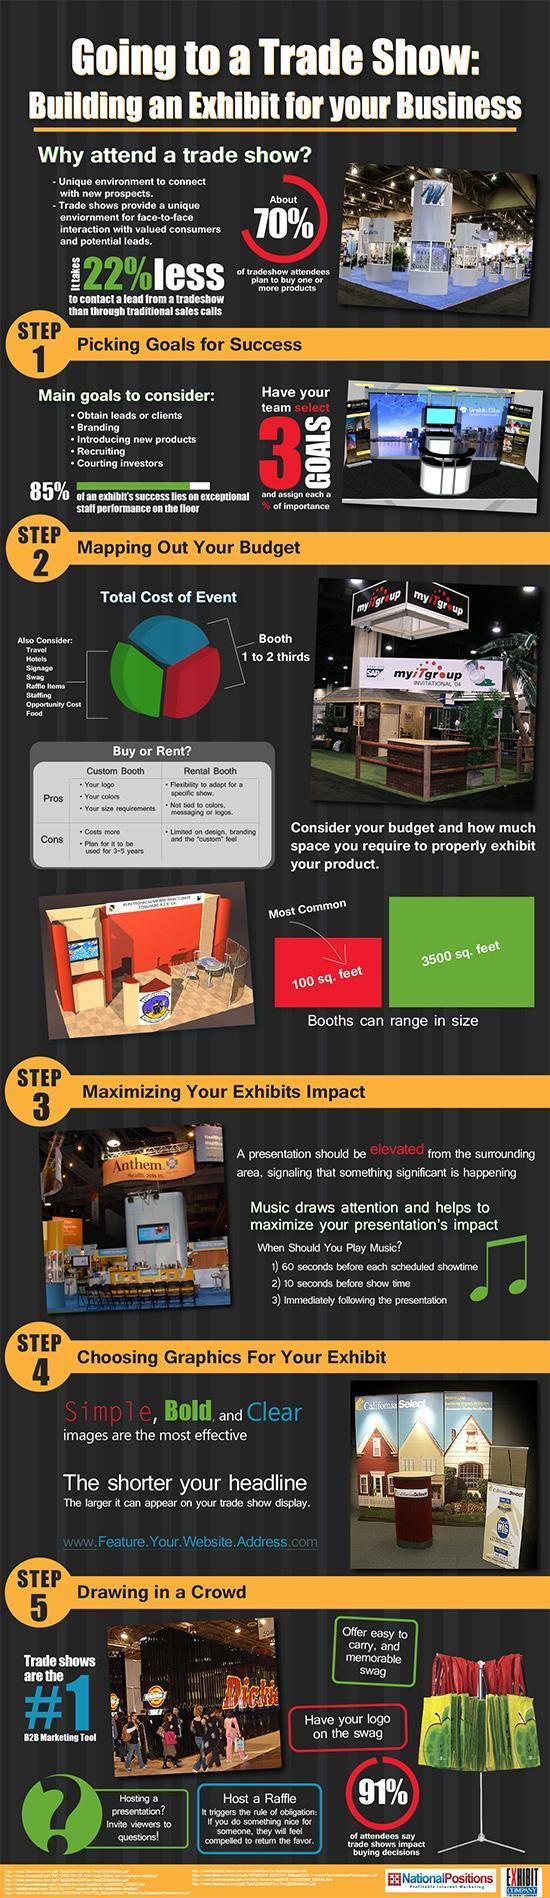What is the most common booth size?
Answer the question with a short phrase. 100 sq. feet 